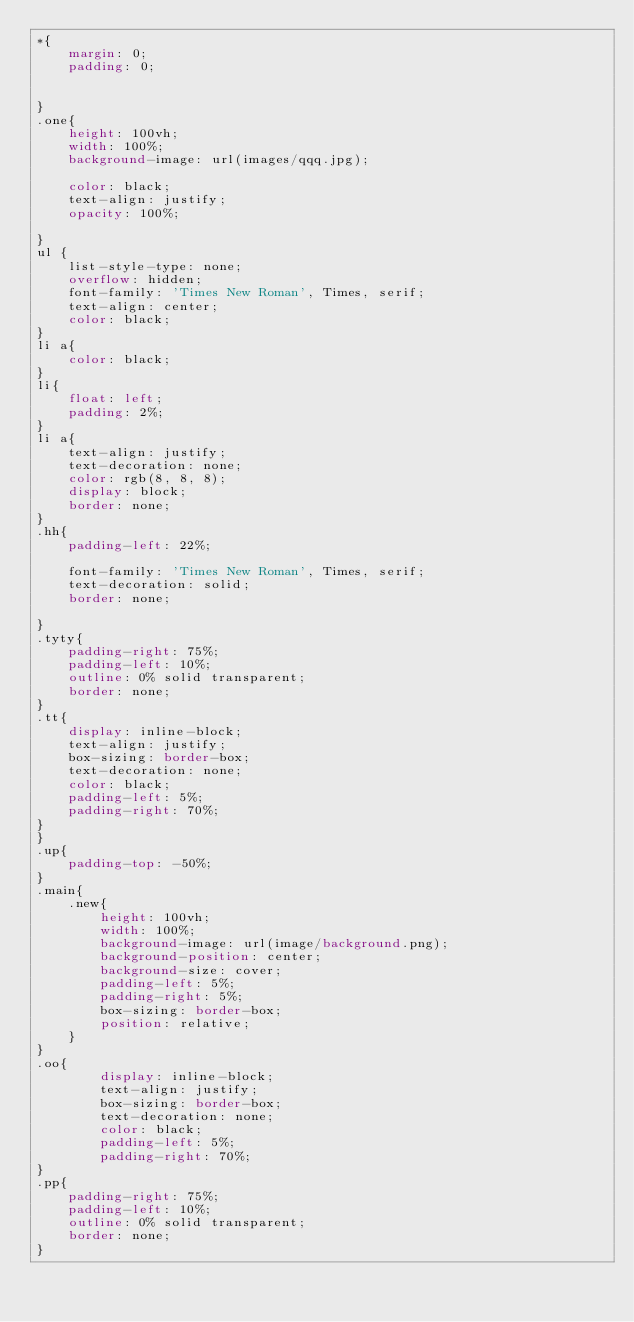<code> <loc_0><loc_0><loc_500><loc_500><_CSS_>*{
    margin: 0;
    padding: 0;

    
}
.one{
    height: 100vh;
    width: 100%;
    background-image: url(images/qqq.jpg);
    
    color: black;
    text-align: justify;
    opacity: 100%;

}
ul {
    list-style-type: none;
    overflow: hidden;
    font-family: 'Times New Roman', Times, serif;
    text-align: center;
    color: black;
}
li a{
    color: black;
}
li{
    float: left;
    padding: 2%;
}
li a{
    text-align: justify;
    text-decoration: none;
    color: rgb(8, 8, 8);
    display: block;
    border: none;
}
.hh{
    padding-left: 22%;

    font-family: 'Times New Roman', Times, serif;
    text-decoration: solid;
    border: none;
    
}
.tyty{
    padding-right: 75%;
    padding-left: 10%;
    outline: 0% solid transparent;
    border: none;
}
.tt{
    display: inline-block;
    text-align: justify;
    box-sizing: border-box;
    text-decoration: none;
    color: black;
    padding-left: 5%;
    padding-right: 70%;
}
}
.up{
    padding-top: -50%;
}
.main{
    .new{
        height: 100vh;
        width: 100%;
        background-image: url(image/background.png);
        background-position: center;
        background-size: cover;
        padding-left: 5%;
        padding-right: 5%;
        box-sizing: border-box;
        position: relative;
    }
}
.oo{
        display: inline-block;
        text-align: justify;
        box-sizing: border-box;
        text-decoration: none;
        color: black;
        padding-left: 5%;
        padding-right: 70%;
}
.pp{
    padding-right: 75%;
    padding-left: 10%;
    outline: 0% solid transparent;
    border: none;
}</code> 